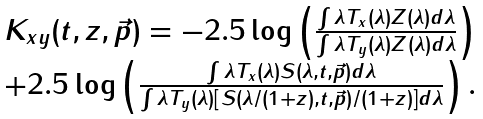Convert formula to latex. <formula><loc_0><loc_0><loc_500><loc_500>\begin{array} { c } K _ { x y } ( t , z , \vec { p } ) = - 2 . 5 \log \left ( \frac { \int \lambda T _ { x } ( \lambda ) Z ( \lambda ) d \lambda } { \int \lambda T _ { y } ( \lambda ) Z ( \lambda ) d \lambda } \right ) \\ + 2 . 5 \log \left ( \frac { \int \lambda T _ { x } ( \lambda ) S ( \lambda , t , \vec { p } ) d \lambda } { \int \lambda T _ { y } ( \lambda ) \left [ S \left ( \lambda / ( 1 + z ) , t , \vec { p } \right ) / ( 1 + z ) \right ] d \lambda } \right ) . \end{array}</formula> 